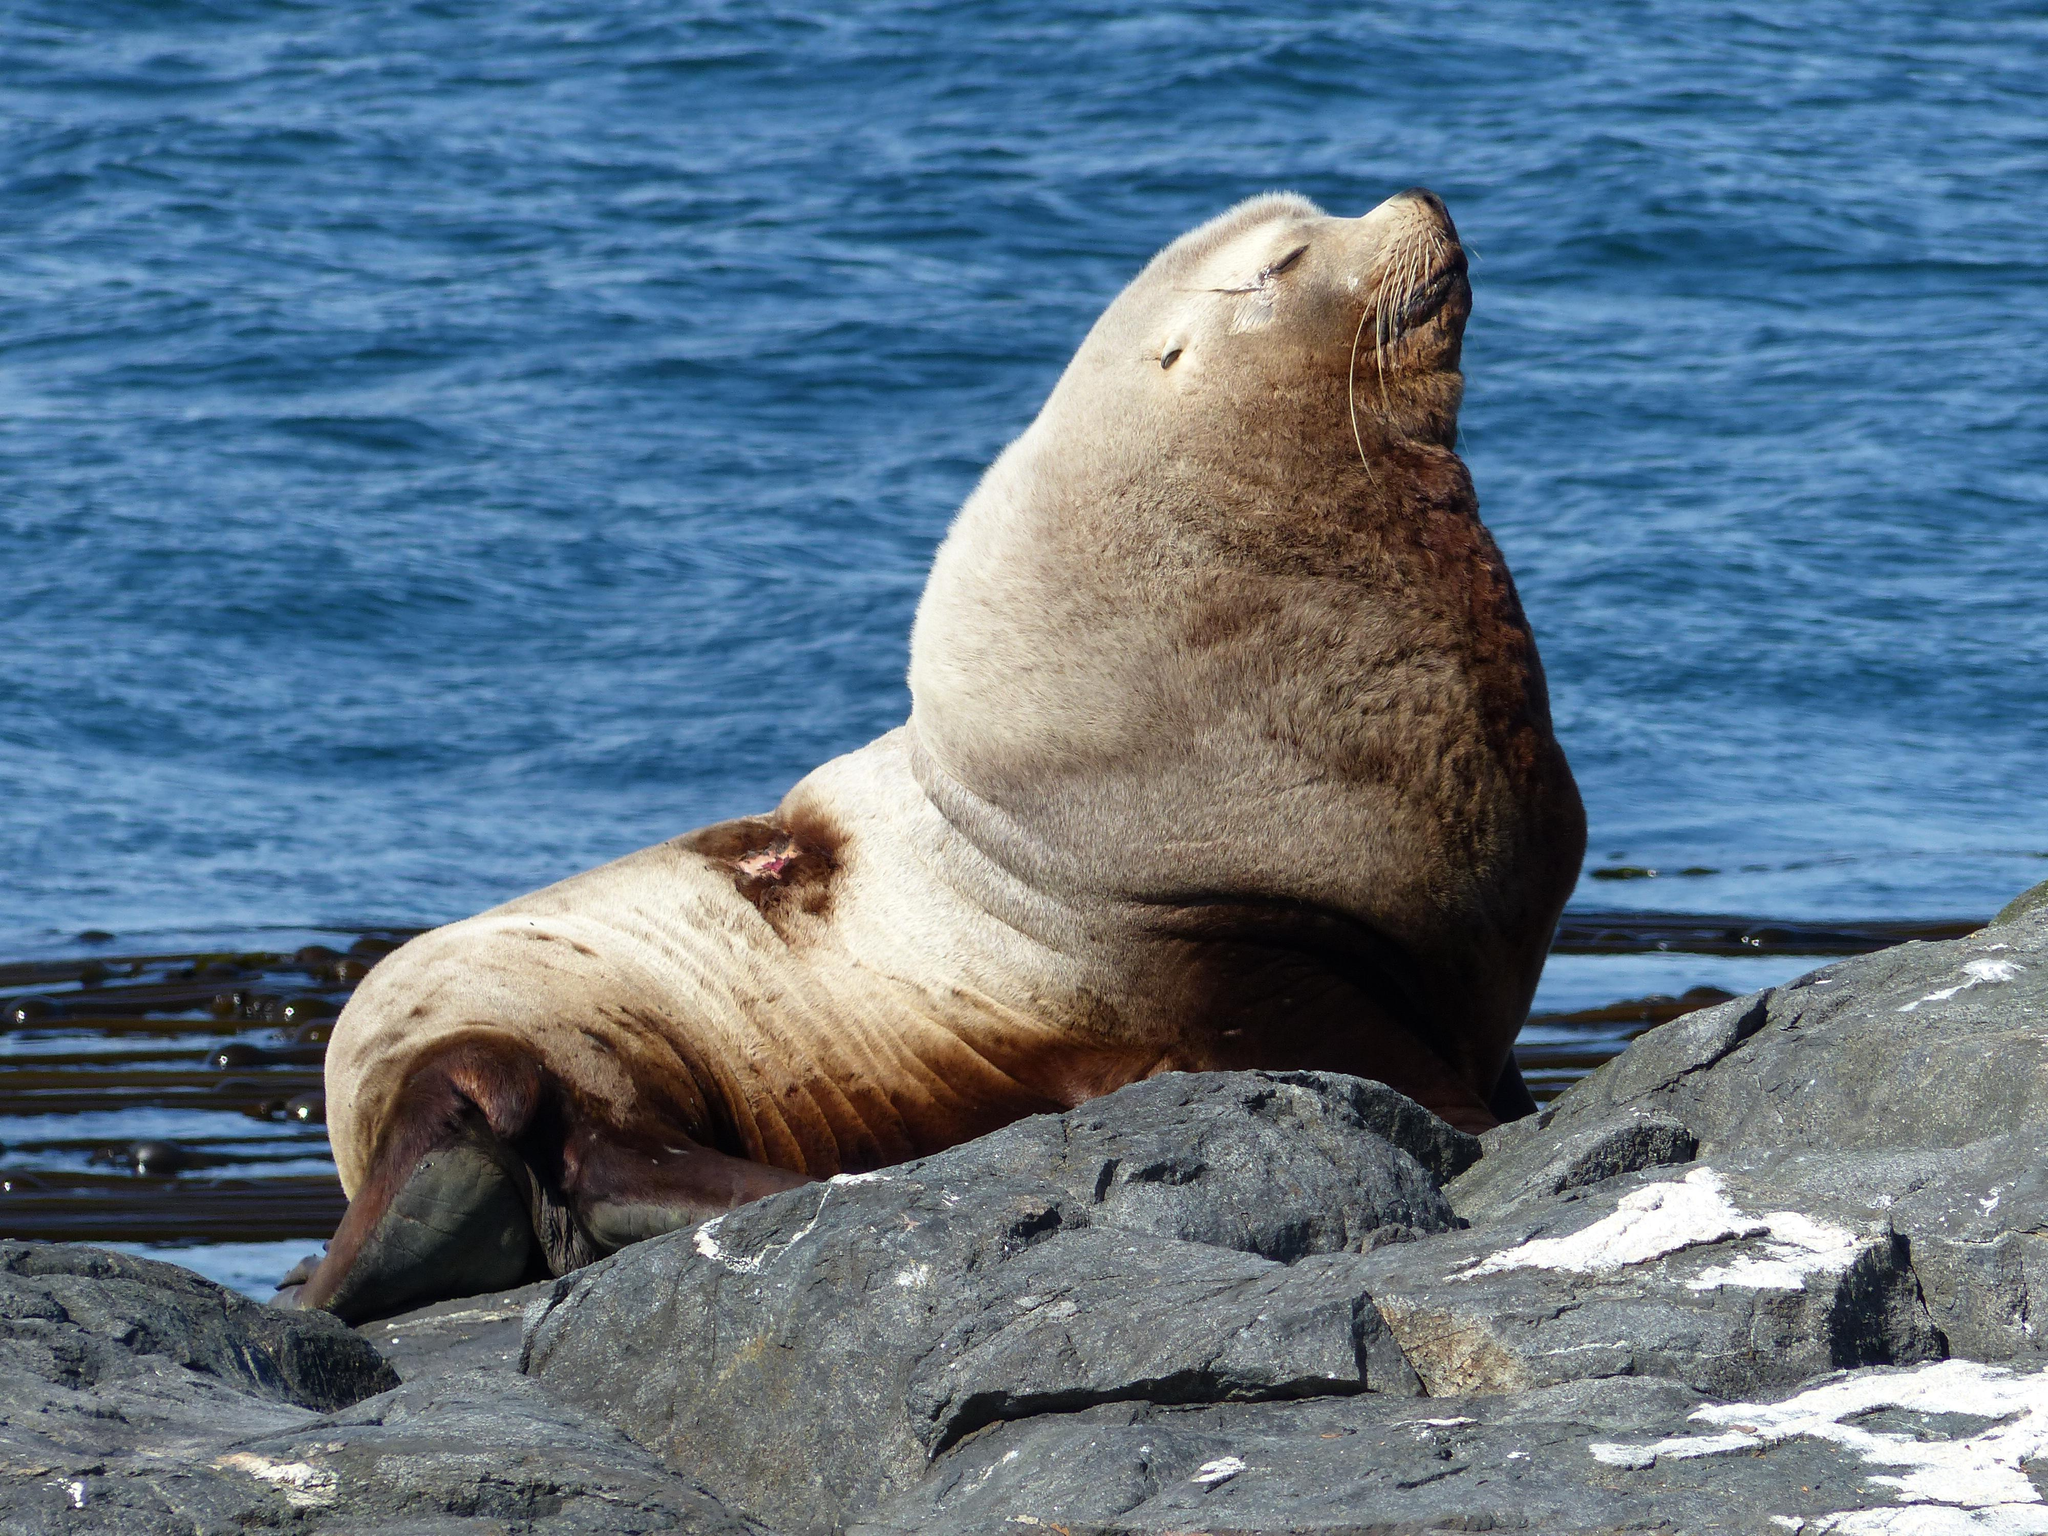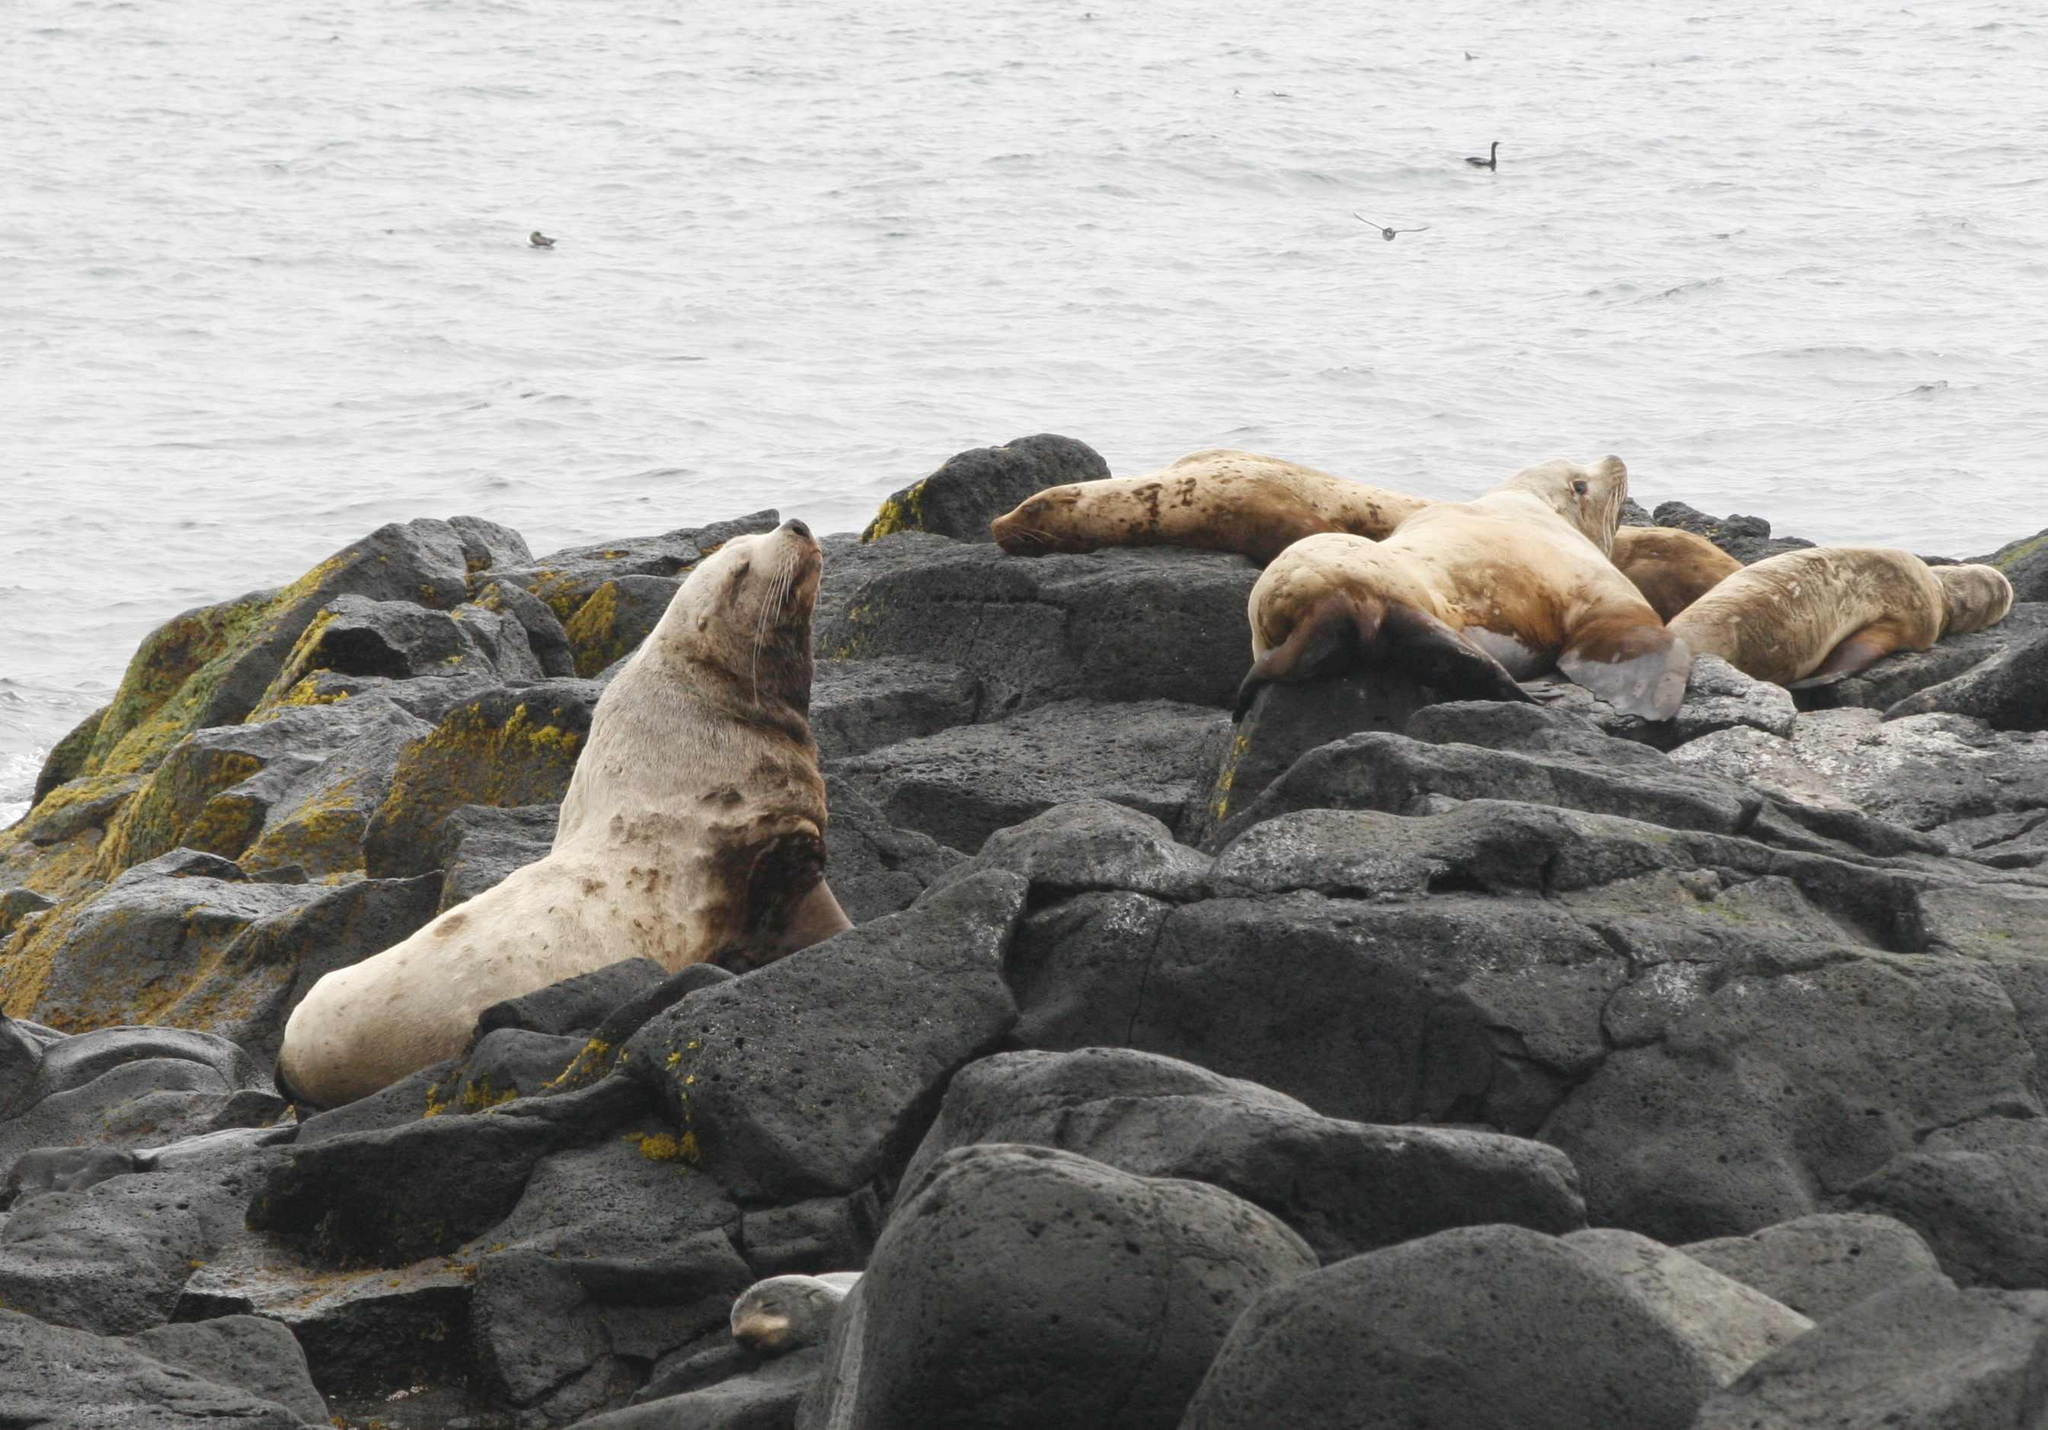The first image is the image on the left, the second image is the image on the right. For the images shown, is this caption "In each image, a large seal has its head and shoulders upright, and the upright seals in the left and right images face the same direction." true? Answer yes or no. Yes. The first image is the image on the left, the second image is the image on the right. Analyze the images presented: Is the assertion "The left image contains exactly one sea lion." valid? Answer yes or no. Yes. 